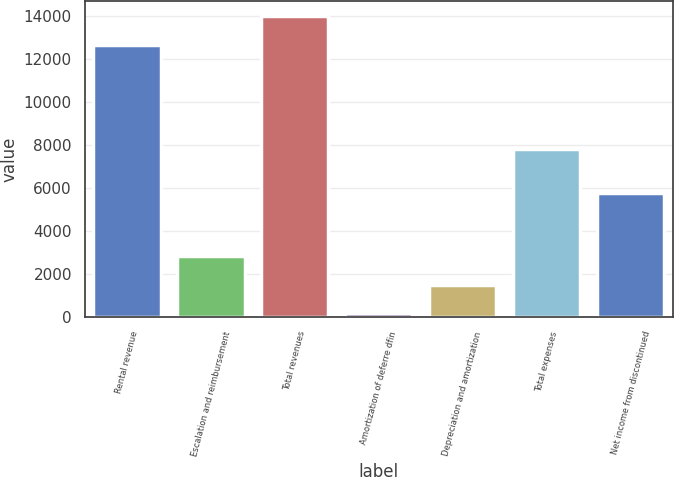<chart> <loc_0><loc_0><loc_500><loc_500><bar_chart><fcel>Rental revenue<fcel>Escalation and reimbursement<fcel>Total revenues<fcel>Amortization of deferre dfin<fcel>Depreciation and amortization<fcel>Total expenses<fcel>Net income from discontinued<nl><fcel>12636<fcel>2851.4<fcel>13975.7<fcel>172<fcel>1511.7<fcel>7789<fcel>5780<nl></chart> 